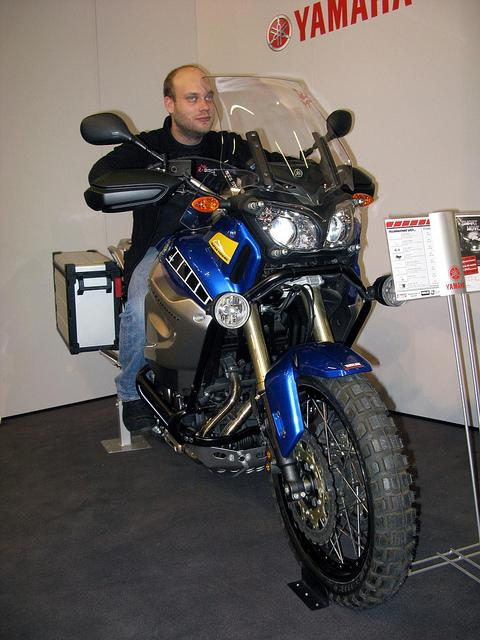What brand is the motorcycle? yamaha 